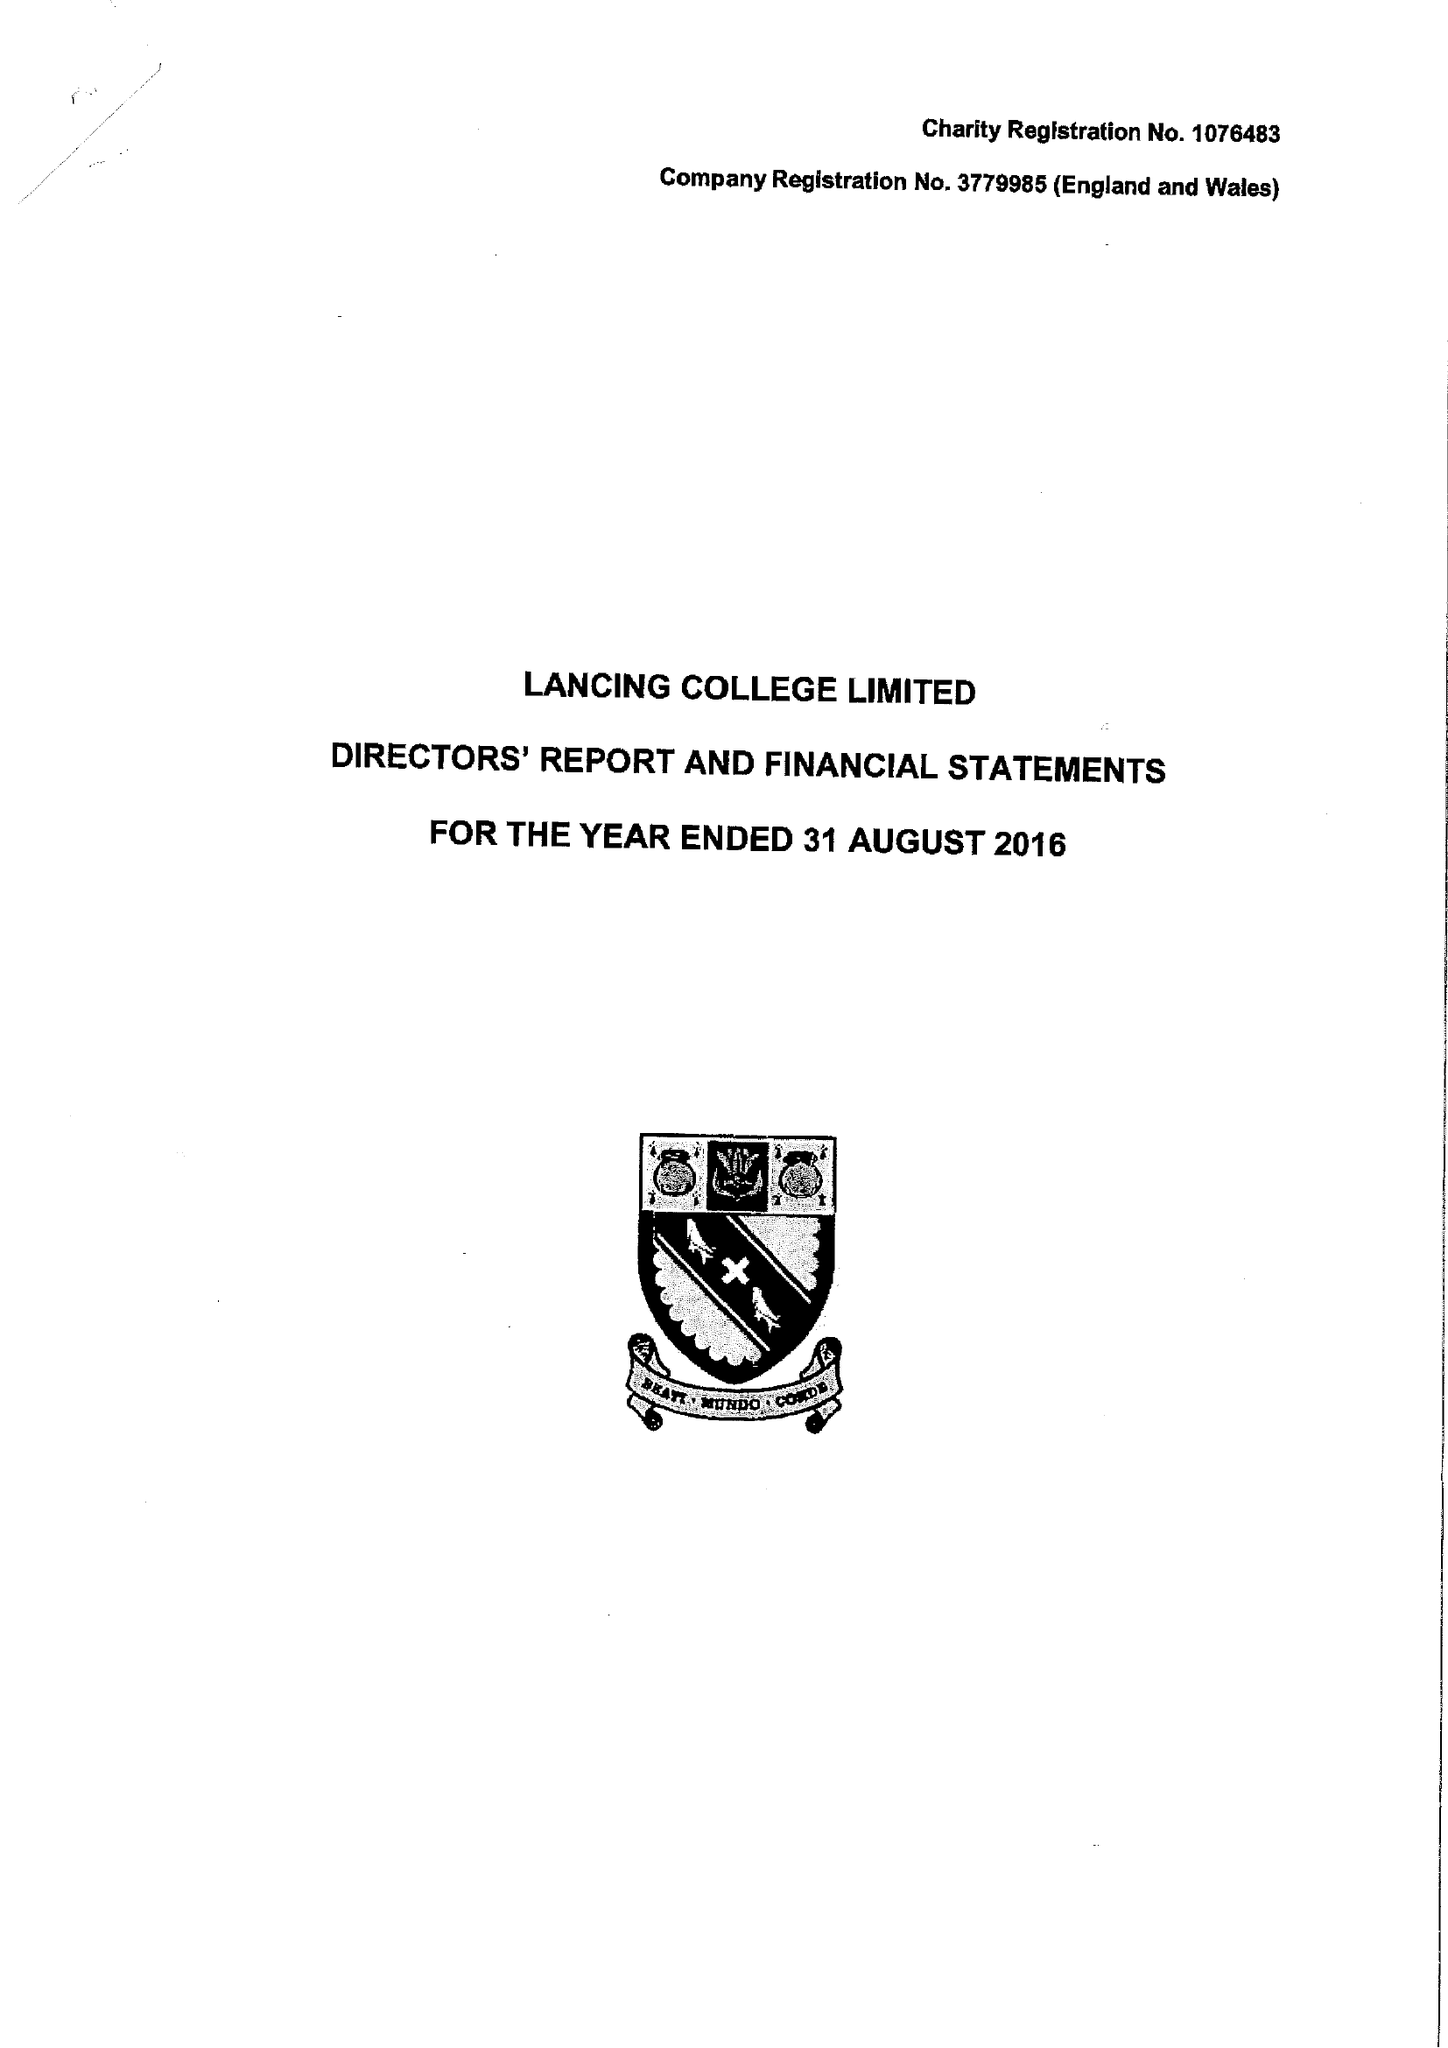What is the value for the address__post_town?
Answer the question using a single word or phrase. LANCING 